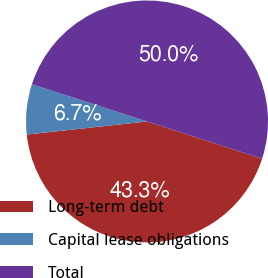<chart> <loc_0><loc_0><loc_500><loc_500><pie_chart><fcel>Long-term debt<fcel>Capital lease obligations<fcel>Total<nl><fcel>43.29%<fcel>6.71%<fcel>50.0%<nl></chart> 